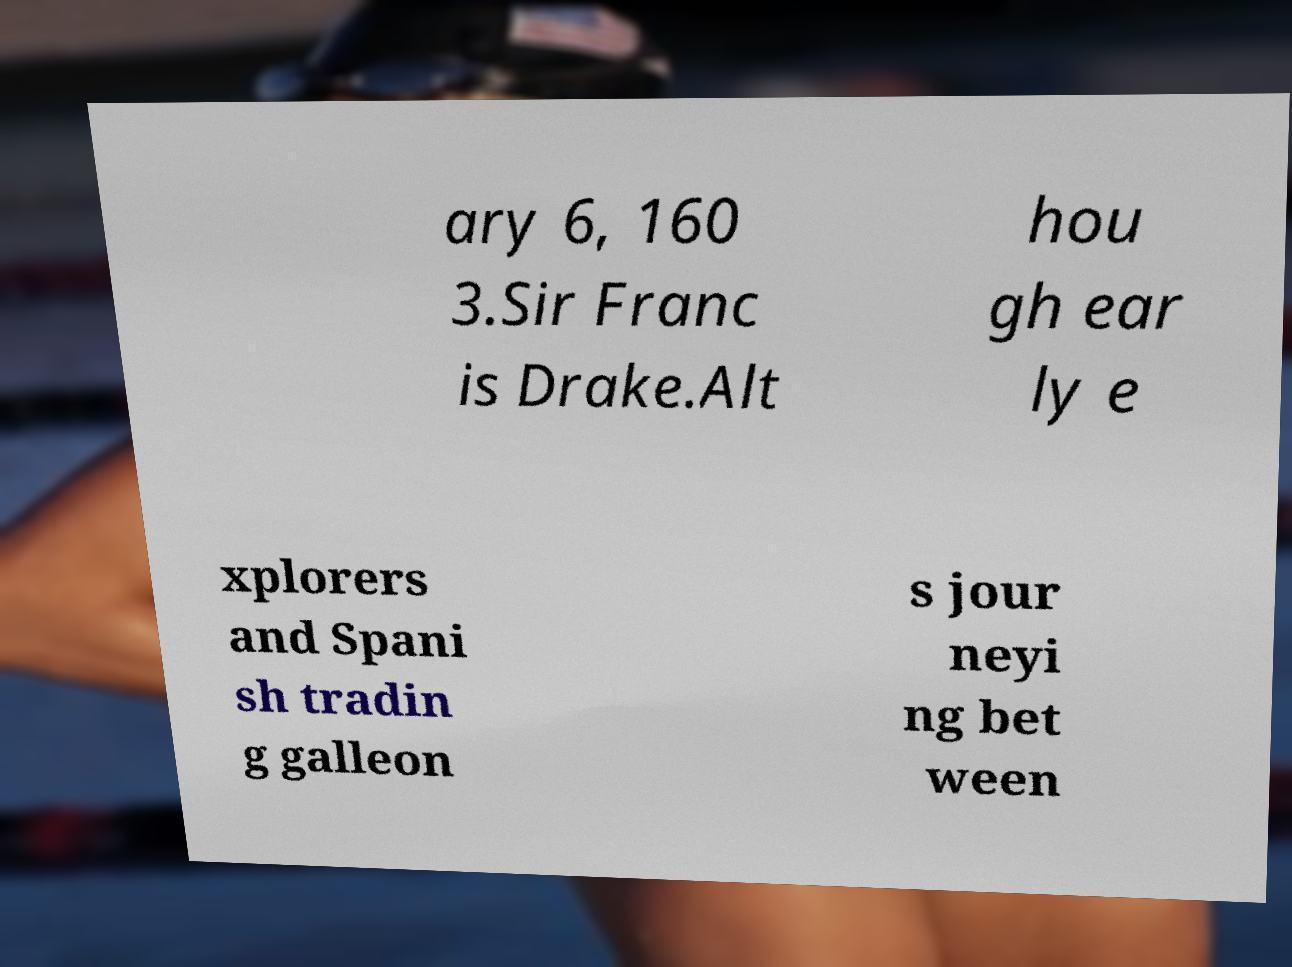Could you extract and type out the text from this image? ary 6, 160 3.Sir Franc is Drake.Alt hou gh ear ly e xplorers and Spani sh tradin g galleon s jour neyi ng bet ween 